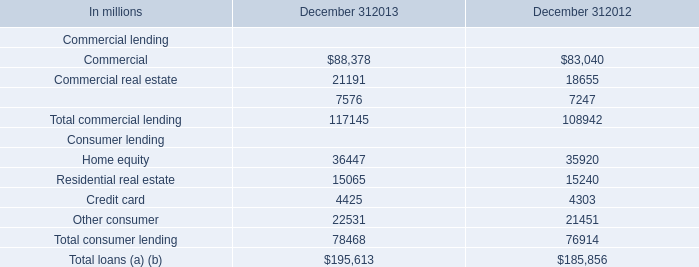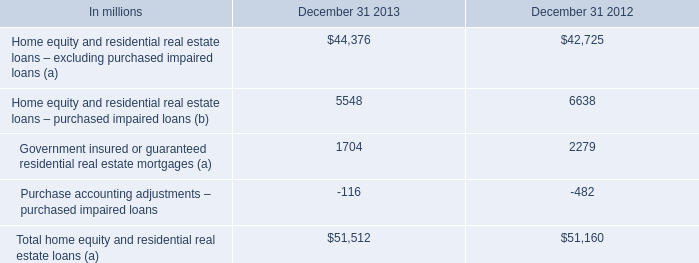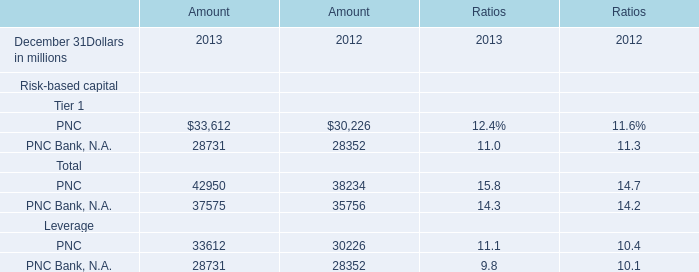Which year ended December 31 is the Amount for Risk-based capital Total:PNC Bank, N.A. the lowest? 
Answer: 2012. 